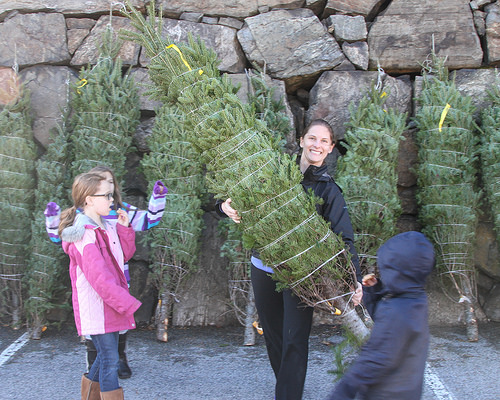<image>
Can you confirm if the woman is in front of the tree? No. The woman is not in front of the tree. The spatial positioning shows a different relationship between these objects. 